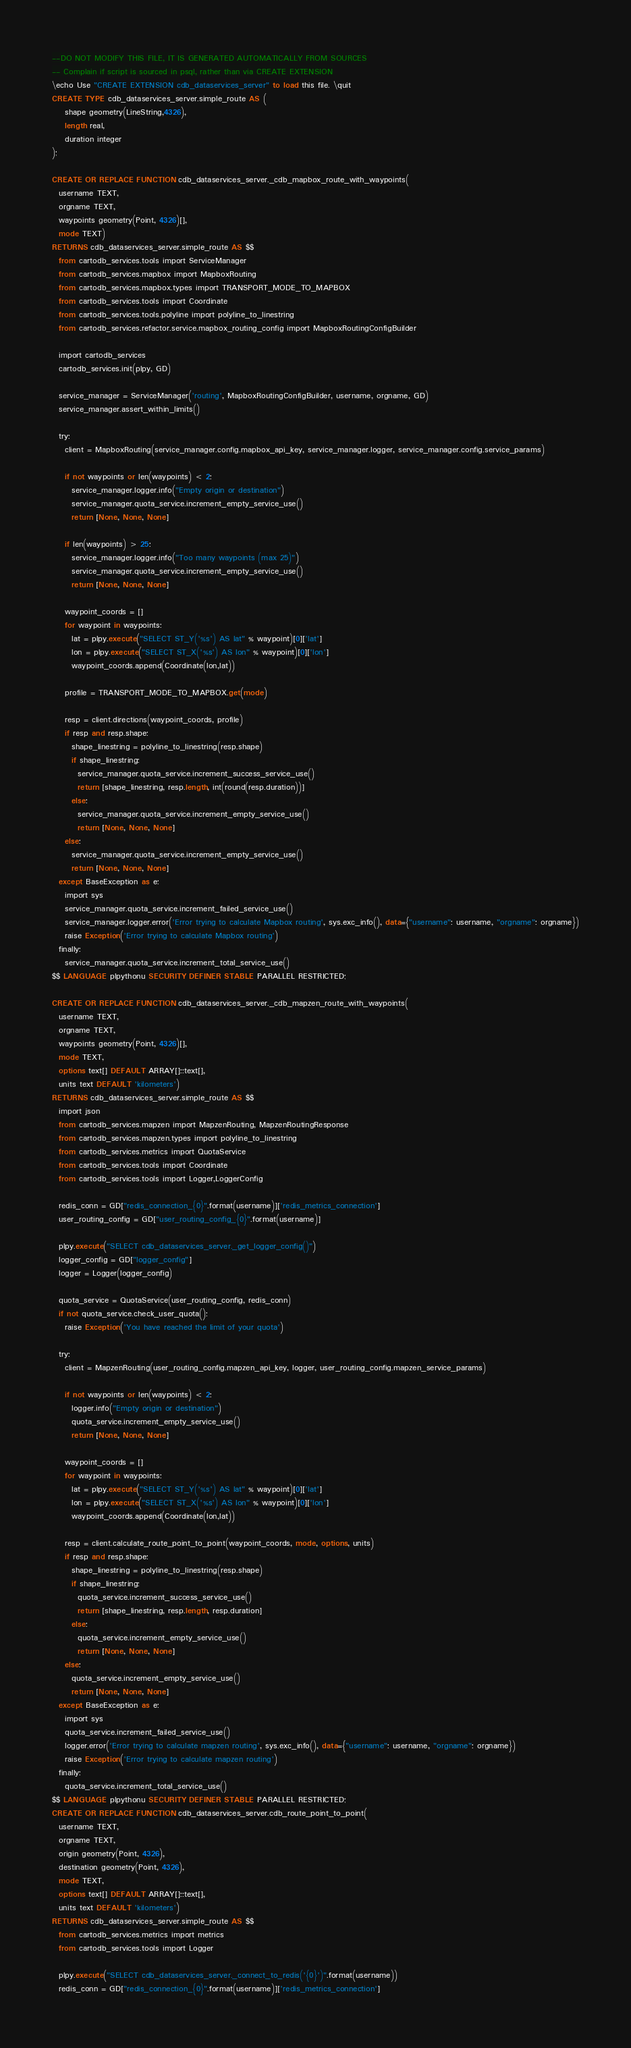Convert code to text. <code><loc_0><loc_0><loc_500><loc_500><_SQL_>--DO NOT MODIFY THIS FILE, IT IS GENERATED AUTOMATICALLY FROM SOURCES
-- Complain if script is sourced in psql, rather than via CREATE EXTENSION
\echo Use "CREATE EXTENSION cdb_dataservices_server" to load this file. \quit
CREATE TYPE cdb_dataservices_server.simple_route AS (
    shape geometry(LineString,4326),
    length real,
    duration integer
);

CREATE OR REPLACE FUNCTION cdb_dataservices_server._cdb_mapbox_route_with_waypoints(
  username TEXT,
  orgname TEXT,
  waypoints geometry(Point, 4326)[],
  mode TEXT)
RETURNS cdb_dataservices_server.simple_route AS $$
  from cartodb_services.tools import ServiceManager
  from cartodb_services.mapbox import MapboxRouting
  from cartodb_services.mapbox.types import TRANSPORT_MODE_TO_MAPBOX
  from cartodb_services.tools import Coordinate
  from cartodb_services.tools.polyline import polyline_to_linestring
  from cartodb_services.refactor.service.mapbox_routing_config import MapboxRoutingConfigBuilder

  import cartodb_services
  cartodb_services.init(plpy, GD)

  service_manager = ServiceManager('routing', MapboxRoutingConfigBuilder, username, orgname, GD)
  service_manager.assert_within_limits()

  try:
    client = MapboxRouting(service_manager.config.mapbox_api_key, service_manager.logger, service_manager.config.service_params)

    if not waypoints or len(waypoints) < 2:
      service_manager.logger.info("Empty origin or destination")
      service_manager.quota_service.increment_empty_service_use()
      return [None, None, None]

    if len(waypoints) > 25:
      service_manager.logger.info("Too many waypoints (max 25)")
      service_manager.quota_service.increment_empty_service_use()
      return [None, None, None]

    waypoint_coords = []
    for waypoint in waypoints:
      lat = plpy.execute("SELECT ST_Y('%s') AS lat" % waypoint)[0]['lat']
      lon = plpy.execute("SELECT ST_X('%s') AS lon" % waypoint)[0]['lon']
      waypoint_coords.append(Coordinate(lon,lat))

    profile = TRANSPORT_MODE_TO_MAPBOX.get(mode)

    resp = client.directions(waypoint_coords, profile)
    if resp and resp.shape:
      shape_linestring = polyline_to_linestring(resp.shape)
      if shape_linestring:
        service_manager.quota_service.increment_success_service_use()
        return [shape_linestring, resp.length, int(round(resp.duration))]
      else:
        service_manager.quota_service.increment_empty_service_use()
        return [None, None, None]
    else:
      service_manager.quota_service.increment_empty_service_use()
      return [None, None, None]
  except BaseException as e:
    import sys
    service_manager.quota_service.increment_failed_service_use()
    service_manager.logger.error('Error trying to calculate Mapbox routing', sys.exc_info(), data={"username": username, "orgname": orgname})
    raise Exception('Error trying to calculate Mapbox routing')
  finally:
    service_manager.quota_service.increment_total_service_use()
$$ LANGUAGE plpythonu SECURITY DEFINER STABLE PARALLEL RESTRICTED;

CREATE OR REPLACE FUNCTION cdb_dataservices_server._cdb_mapzen_route_with_waypoints(
  username TEXT,
  orgname TEXT,
  waypoints geometry(Point, 4326)[],
  mode TEXT,
  options text[] DEFAULT ARRAY[]::text[],
  units text DEFAULT 'kilometers')
RETURNS cdb_dataservices_server.simple_route AS $$
  import json
  from cartodb_services.mapzen import MapzenRouting, MapzenRoutingResponse
  from cartodb_services.mapzen.types import polyline_to_linestring
  from cartodb_services.metrics import QuotaService
  from cartodb_services.tools import Coordinate
  from cartodb_services.tools import Logger,LoggerConfig

  redis_conn = GD["redis_connection_{0}".format(username)]['redis_metrics_connection']
  user_routing_config = GD["user_routing_config_{0}".format(username)]

  plpy.execute("SELECT cdb_dataservices_server._get_logger_config()")
  logger_config = GD["logger_config"]
  logger = Logger(logger_config)

  quota_service = QuotaService(user_routing_config, redis_conn)
  if not quota_service.check_user_quota():
    raise Exception('You have reached the limit of your quota')

  try:
    client = MapzenRouting(user_routing_config.mapzen_api_key, logger, user_routing_config.mapzen_service_params)

    if not waypoints or len(waypoints) < 2:
      logger.info("Empty origin or destination")
      quota_service.increment_empty_service_use()
      return [None, None, None]

    waypoint_coords = []
    for waypoint in waypoints:
      lat = plpy.execute("SELECT ST_Y('%s') AS lat" % waypoint)[0]['lat']
      lon = plpy.execute("SELECT ST_X('%s') AS lon" % waypoint)[0]['lon']
      waypoint_coords.append(Coordinate(lon,lat))

    resp = client.calculate_route_point_to_point(waypoint_coords, mode, options, units)
    if resp and resp.shape:
      shape_linestring = polyline_to_linestring(resp.shape)
      if shape_linestring:
        quota_service.increment_success_service_use()
        return [shape_linestring, resp.length, resp.duration]
      else:
        quota_service.increment_empty_service_use()
        return [None, None, None]
    else:
      quota_service.increment_empty_service_use()
      return [None, None, None]
  except BaseException as e:
    import sys
    quota_service.increment_failed_service_use()
    logger.error('Error trying to calculate mapzen routing', sys.exc_info(), data={"username": username, "orgname": orgname})
    raise Exception('Error trying to calculate mapzen routing')
  finally:
    quota_service.increment_total_service_use()
$$ LANGUAGE plpythonu SECURITY DEFINER STABLE PARALLEL RESTRICTED;
CREATE OR REPLACE FUNCTION cdb_dataservices_server.cdb_route_point_to_point(
  username TEXT,
  orgname TEXT,
  origin geometry(Point, 4326),
  destination geometry(Point, 4326),
  mode TEXT,
  options text[] DEFAULT ARRAY[]::text[],
  units text DEFAULT 'kilometers')
RETURNS cdb_dataservices_server.simple_route AS $$
  from cartodb_services.metrics import metrics
  from cartodb_services.tools import Logger

  plpy.execute("SELECT cdb_dataservices_server._connect_to_redis('{0}')".format(username))
  redis_conn = GD["redis_connection_{0}".format(username)]['redis_metrics_connection']</code> 